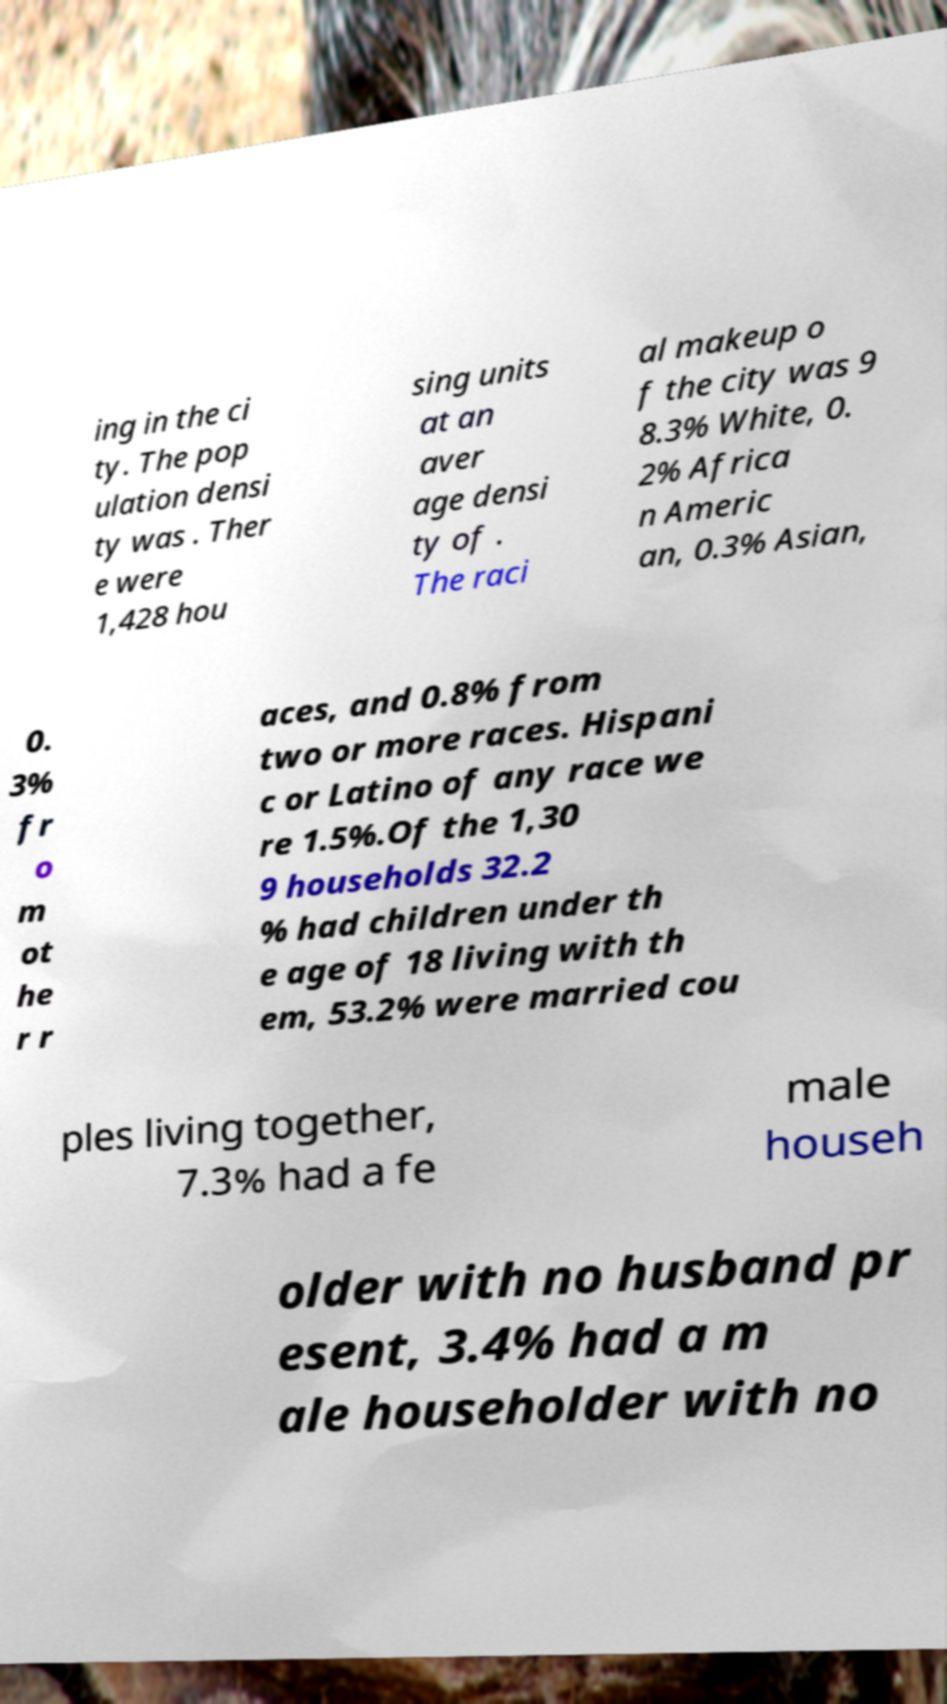Please read and relay the text visible in this image. What does it say? ing in the ci ty. The pop ulation densi ty was . Ther e were 1,428 hou sing units at an aver age densi ty of . The raci al makeup o f the city was 9 8.3% White, 0. 2% Africa n Americ an, 0.3% Asian, 0. 3% fr o m ot he r r aces, and 0.8% from two or more races. Hispani c or Latino of any race we re 1.5%.Of the 1,30 9 households 32.2 % had children under th e age of 18 living with th em, 53.2% were married cou ples living together, 7.3% had a fe male househ older with no husband pr esent, 3.4% had a m ale householder with no 